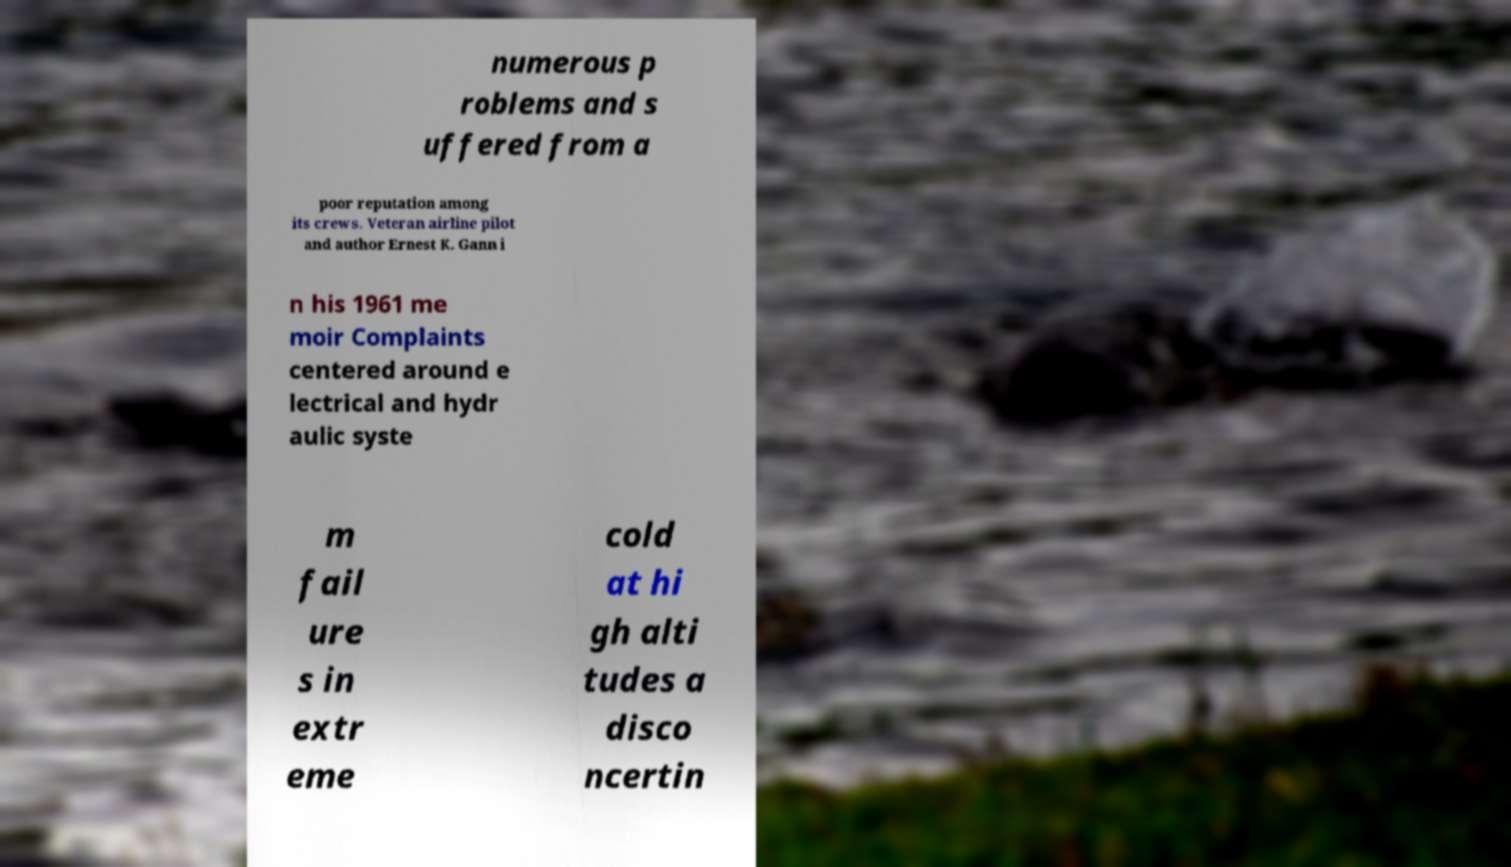For documentation purposes, I need the text within this image transcribed. Could you provide that? numerous p roblems and s uffered from a poor reputation among its crews. Veteran airline pilot and author Ernest K. Gann i n his 1961 me moir Complaints centered around e lectrical and hydr aulic syste m fail ure s in extr eme cold at hi gh alti tudes a disco ncertin 